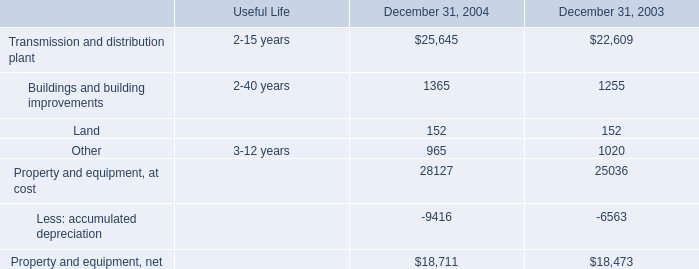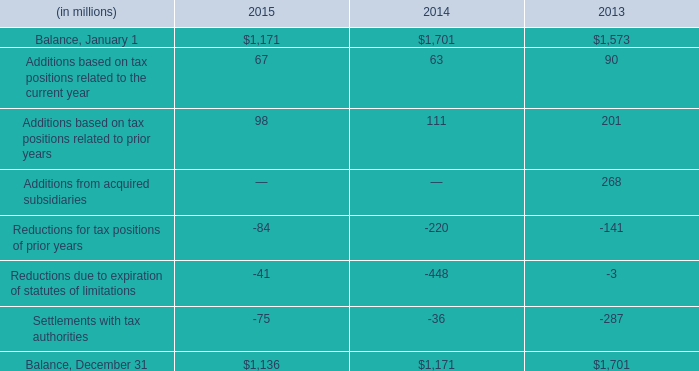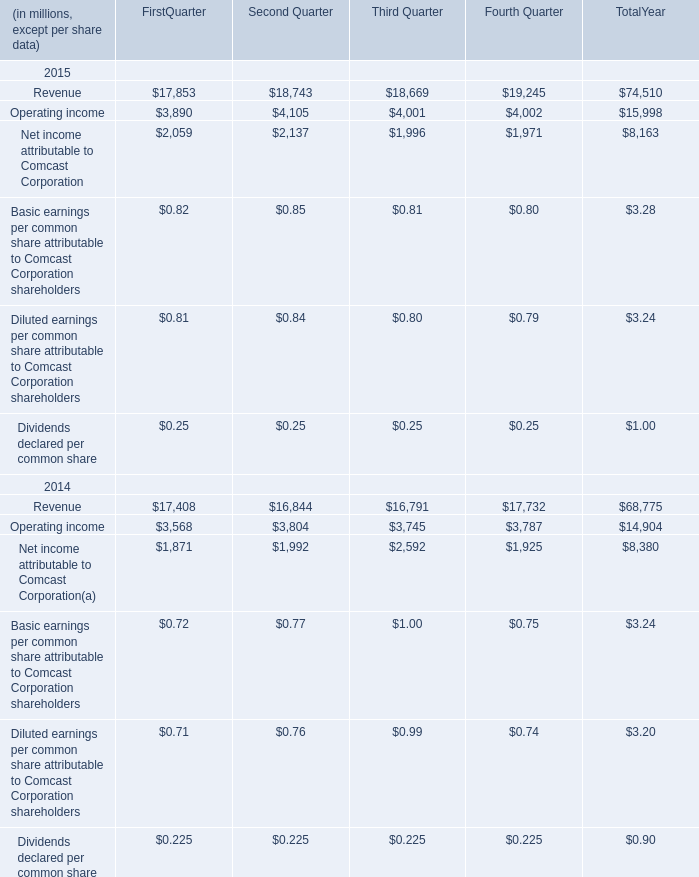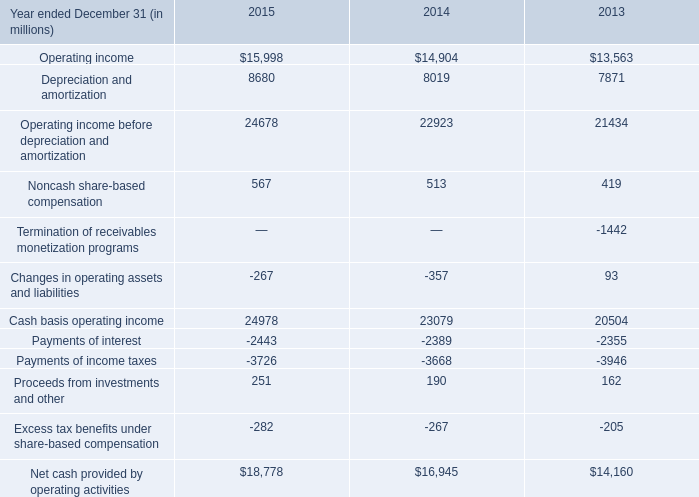What do all operating income sum up without those first quarter smaller than 5000, in 2015? (in million) 
Computations: ((4105 + 4001) + 4002)
Answer: 12108.0. 